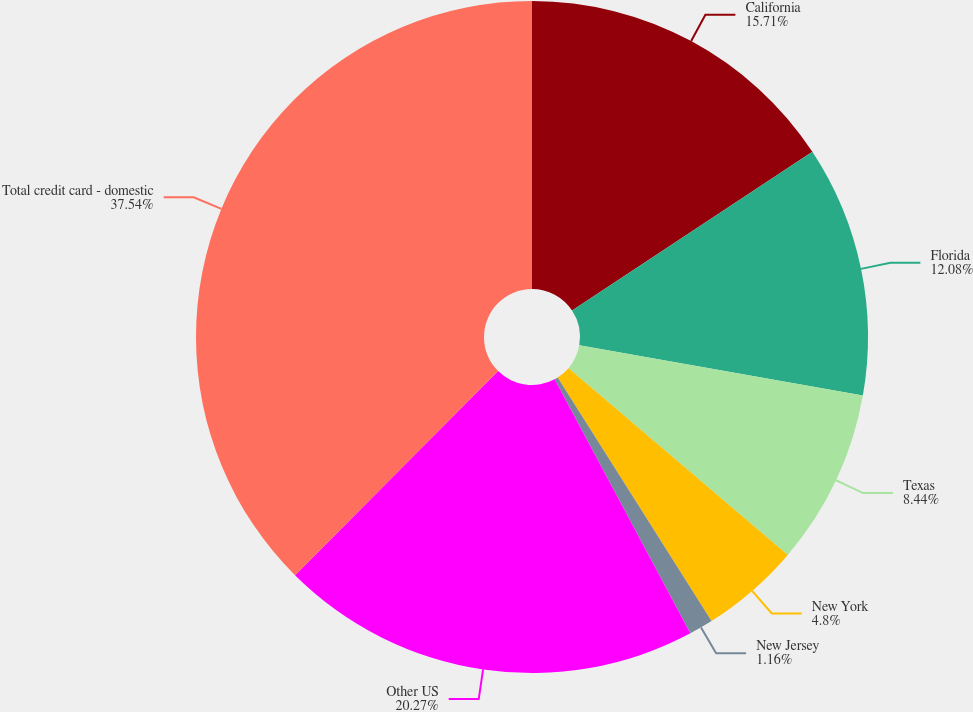Convert chart to OTSL. <chart><loc_0><loc_0><loc_500><loc_500><pie_chart><fcel>California<fcel>Florida<fcel>Texas<fcel>New York<fcel>New Jersey<fcel>Other US<fcel>Total credit card - domestic<nl><fcel>15.71%<fcel>12.08%<fcel>8.44%<fcel>4.8%<fcel>1.16%<fcel>20.27%<fcel>37.54%<nl></chart> 